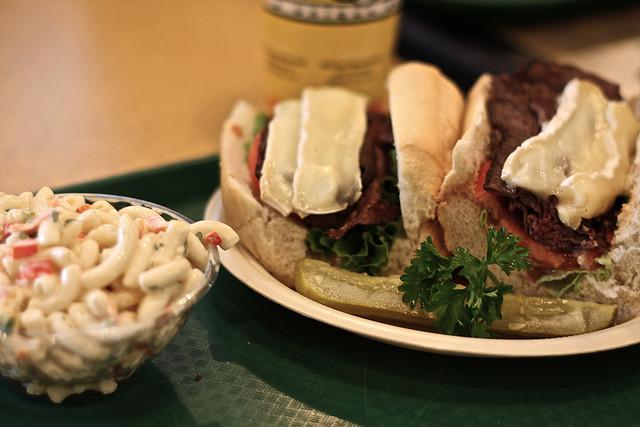What kind of protein is on the sandwich?
Short answer required. Roast beef. How many calories is in the food?
Keep it brief. 800. What object is in the background of this picture?
Short answer required. Drink. Which is considered the side dish?
Quick response, please. Macaroni salad. 